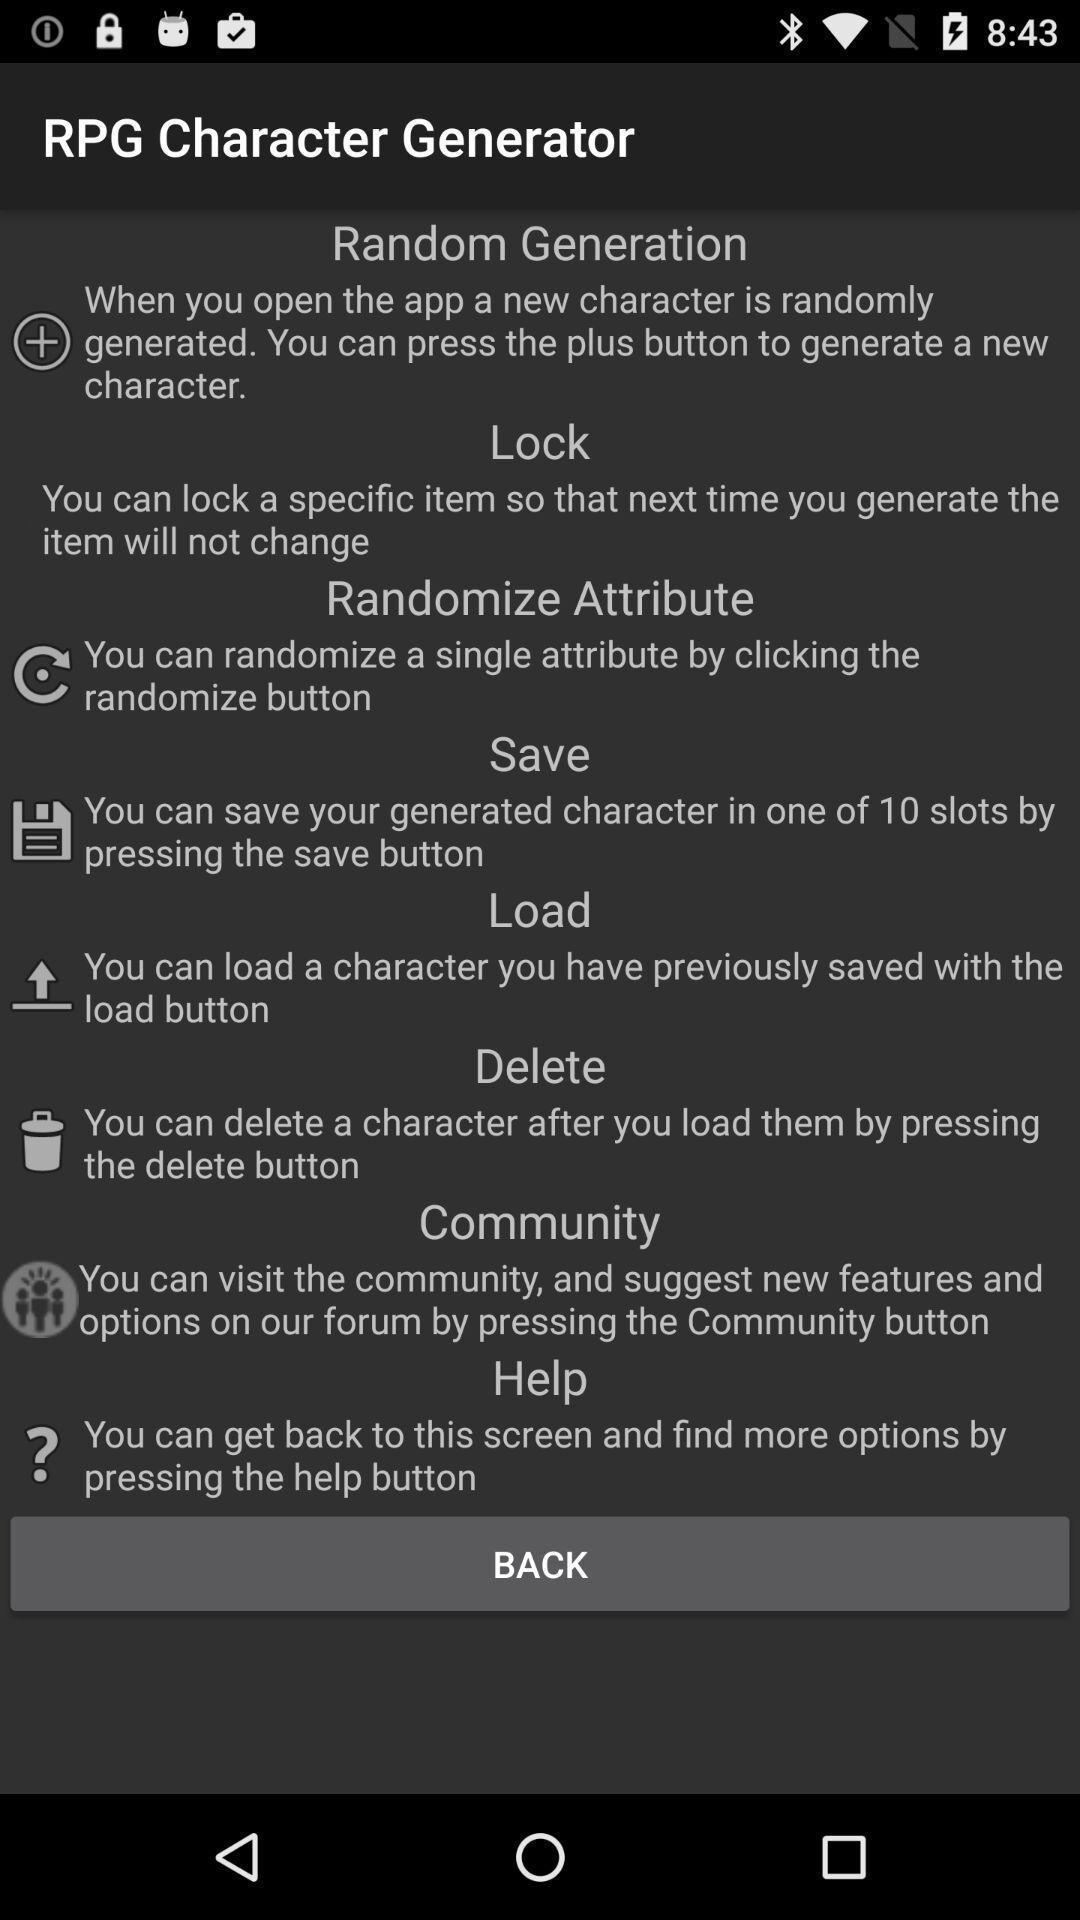Give me a narrative description of this picture. Page displaying information about the gaming app. 